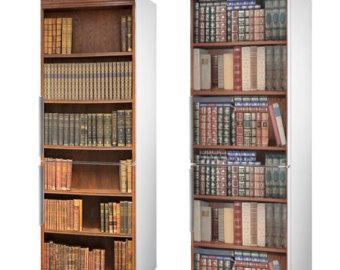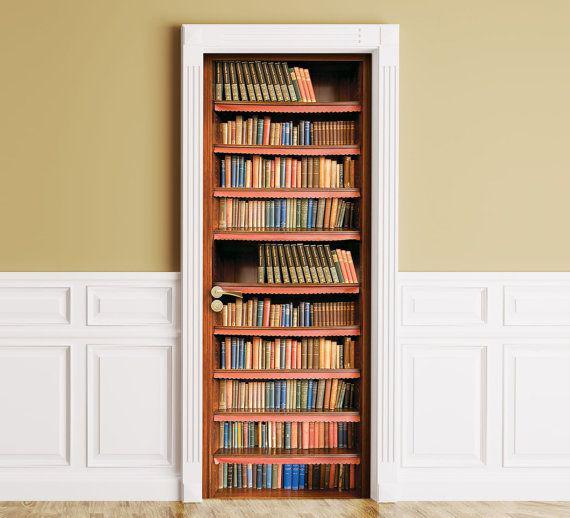The first image is the image on the left, the second image is the image on the right. Evaluate the accuracy of this statement regarding the images: "there is a built in bookcase with white molding and molding on half the wall around it". Is it true? Answer yes or no. Yes. The first image is the image on the left, the second image is the image on the right. Assess this claim about the two images: "One of the bookshelves has wooden cabinet doors at the bottom.". Correct or not? Answer yes or no. No. 